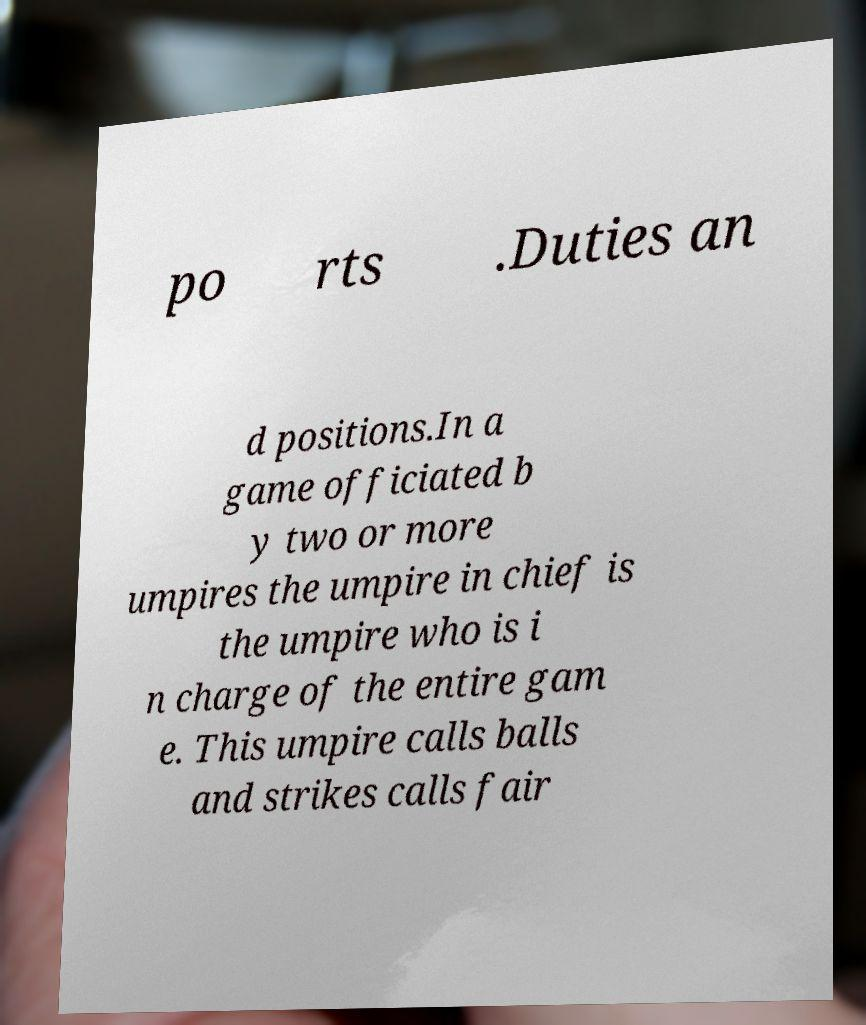There's text embedded in this image that I need extracted. Can you transcribe it verbatim? po rts .Duties an d positions.In a game officiated b y two or more umpires the umpire in chief is the umpire who is i n charge of the entire gam e. This umpire calls balls and strikes calls fair 